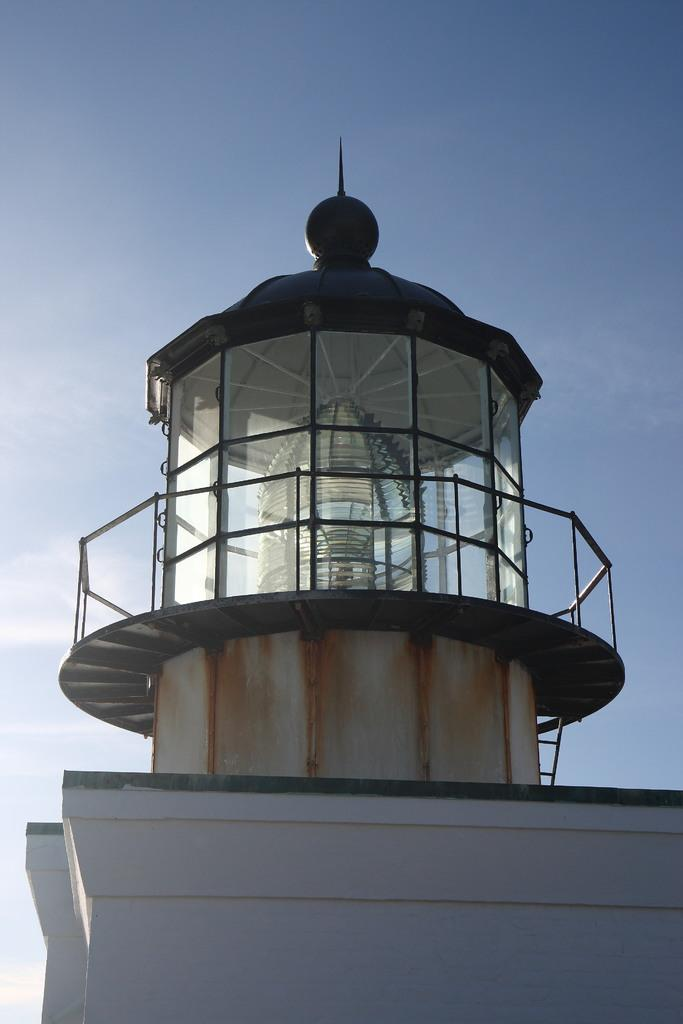What type of structure is in the picture? There is a building in the picture. What feature of the building is mentioned in the facts? The building has stairs and glass windows. How would you describe the weather in the image? The sky is clear and sunny in the image. What type of credit card is being used by the building in the image? There is no credit card or any indication of financial transactions in the image; it features a building with stairs and glass windows. 